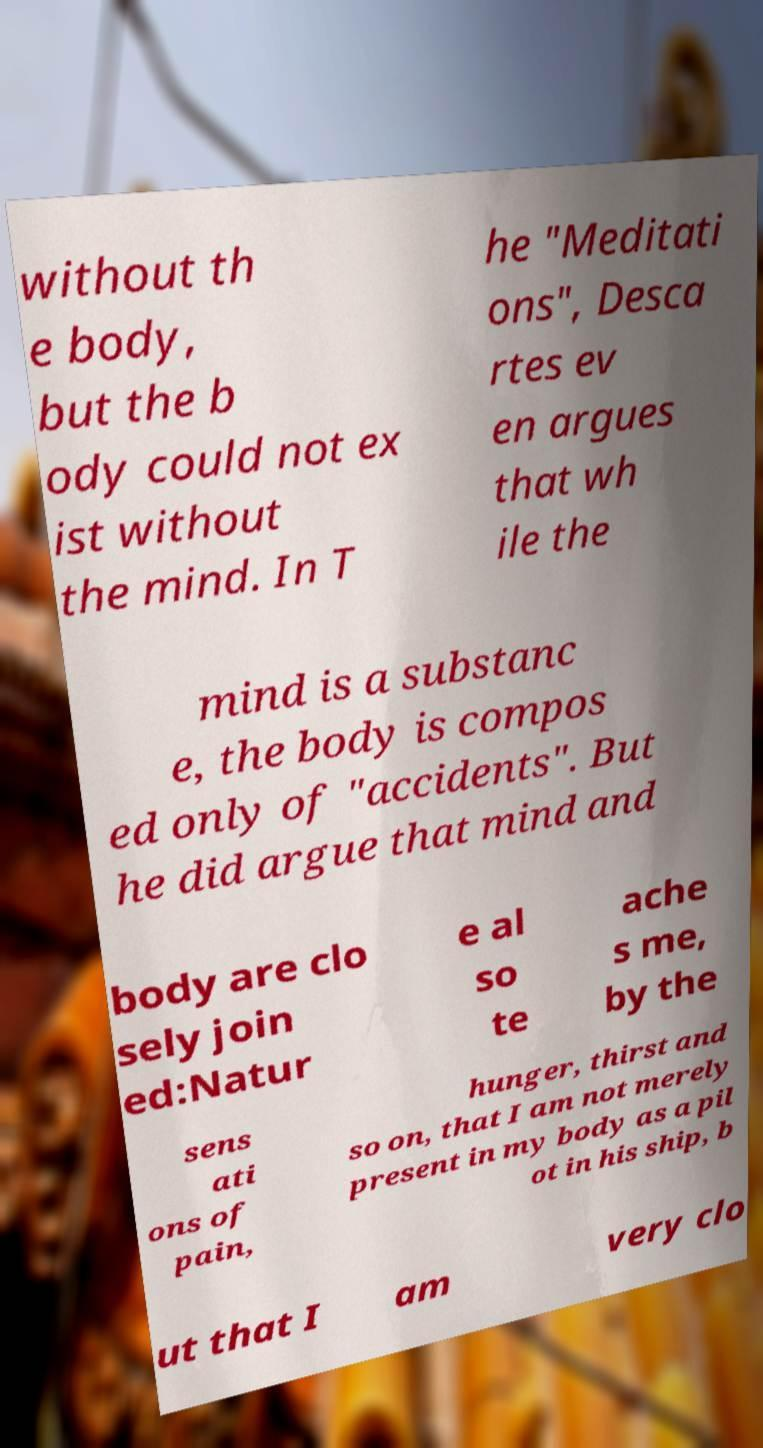I need the written content from this picture converted into text. Can you do that? without th e body, but the b ody could not ex ist without the mind. In T he "Meditati ons", Desca rtes ev en argues that wh ile the mind is a substanc e, the body is compos ed only of "accidents". But he did argue that mind and body are clo sely join ed:Natur e al so te ache s me, by the sens ati ons of pain, hunger, thirst and so on, that I am not merely present in my body as a pil ot in his ship, b ut that I am very clo 